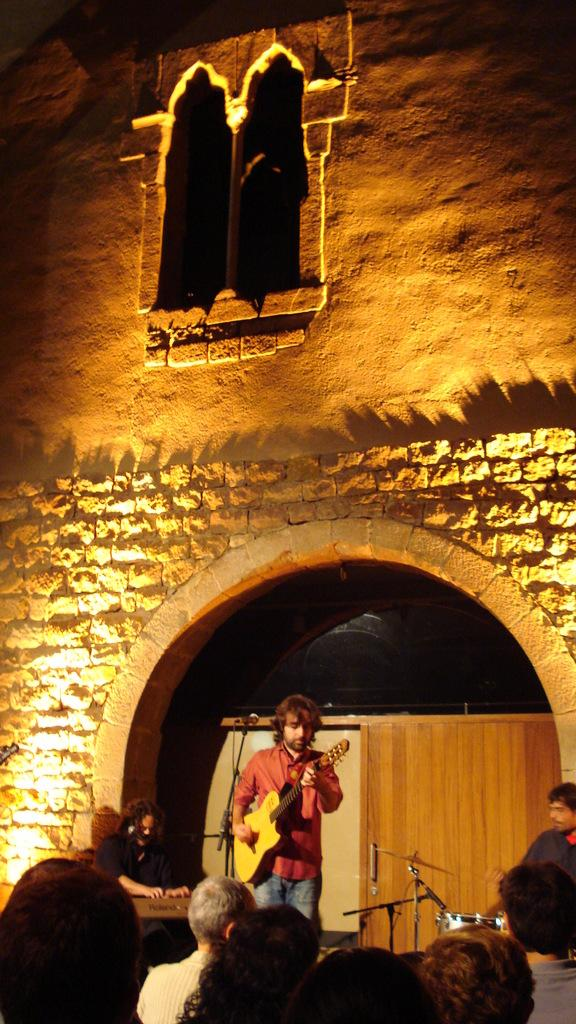How many musicians are playing in the image? There are three people playing musical instruments in the image. What is happening in front of the musicians? There is a group of people in front of the musicians. What can be seen in the background of the image? There is a wall in the background of the image. What type of feather is being used as a neck accessory by one of the musicians? There is no feather or neck accessory visible on any of the musicians in the image. 